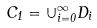<formula> <loc_0><loc_0><loc_500><loc_500>C _ { 1 } = \cup _ { i = 0 } ^ { \infty } D _ { i }</formula> 